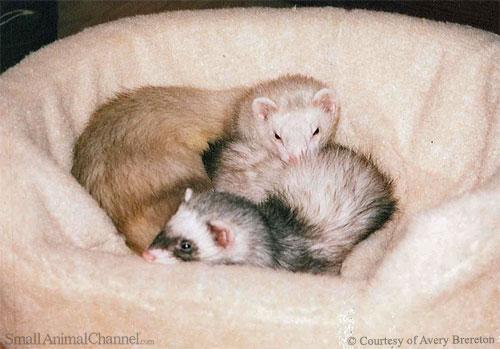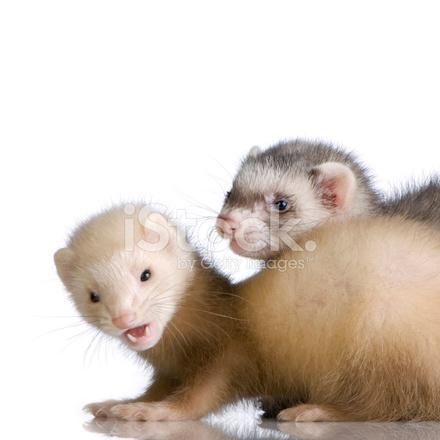The first image is the image on the left, the second image is the image on the right. For the images shown, is this caption "An image contains exactly two ferrets, and one has its head over the other ferret's neck area." true? Answer yes or no. Yes. The first image is the image on the left, the second image is the image on the right. Analyze the images presented: Is the assertion "The right image contains exactly two ferrets." valid? Answer yes or no. Yes. 